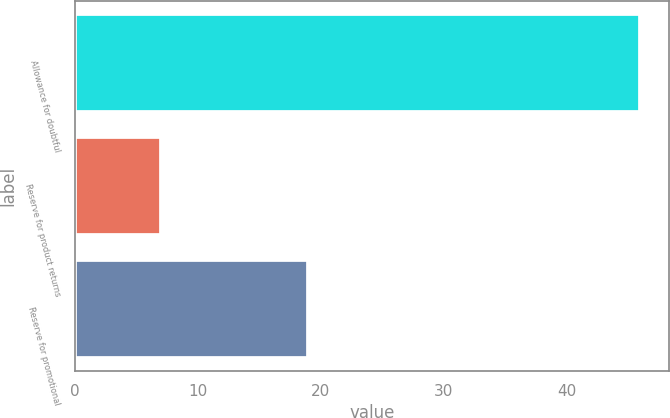Convert chart to OTSL. <chart><loc_0><loc_0><loc_500><loc_500><bar_chart><fcel>Allowance for doubtful<fcel>Reserve for product returns<fcel>Reserve for promotional<nl><fcel>46<fcel>7<fcel>19<nl></chart> 